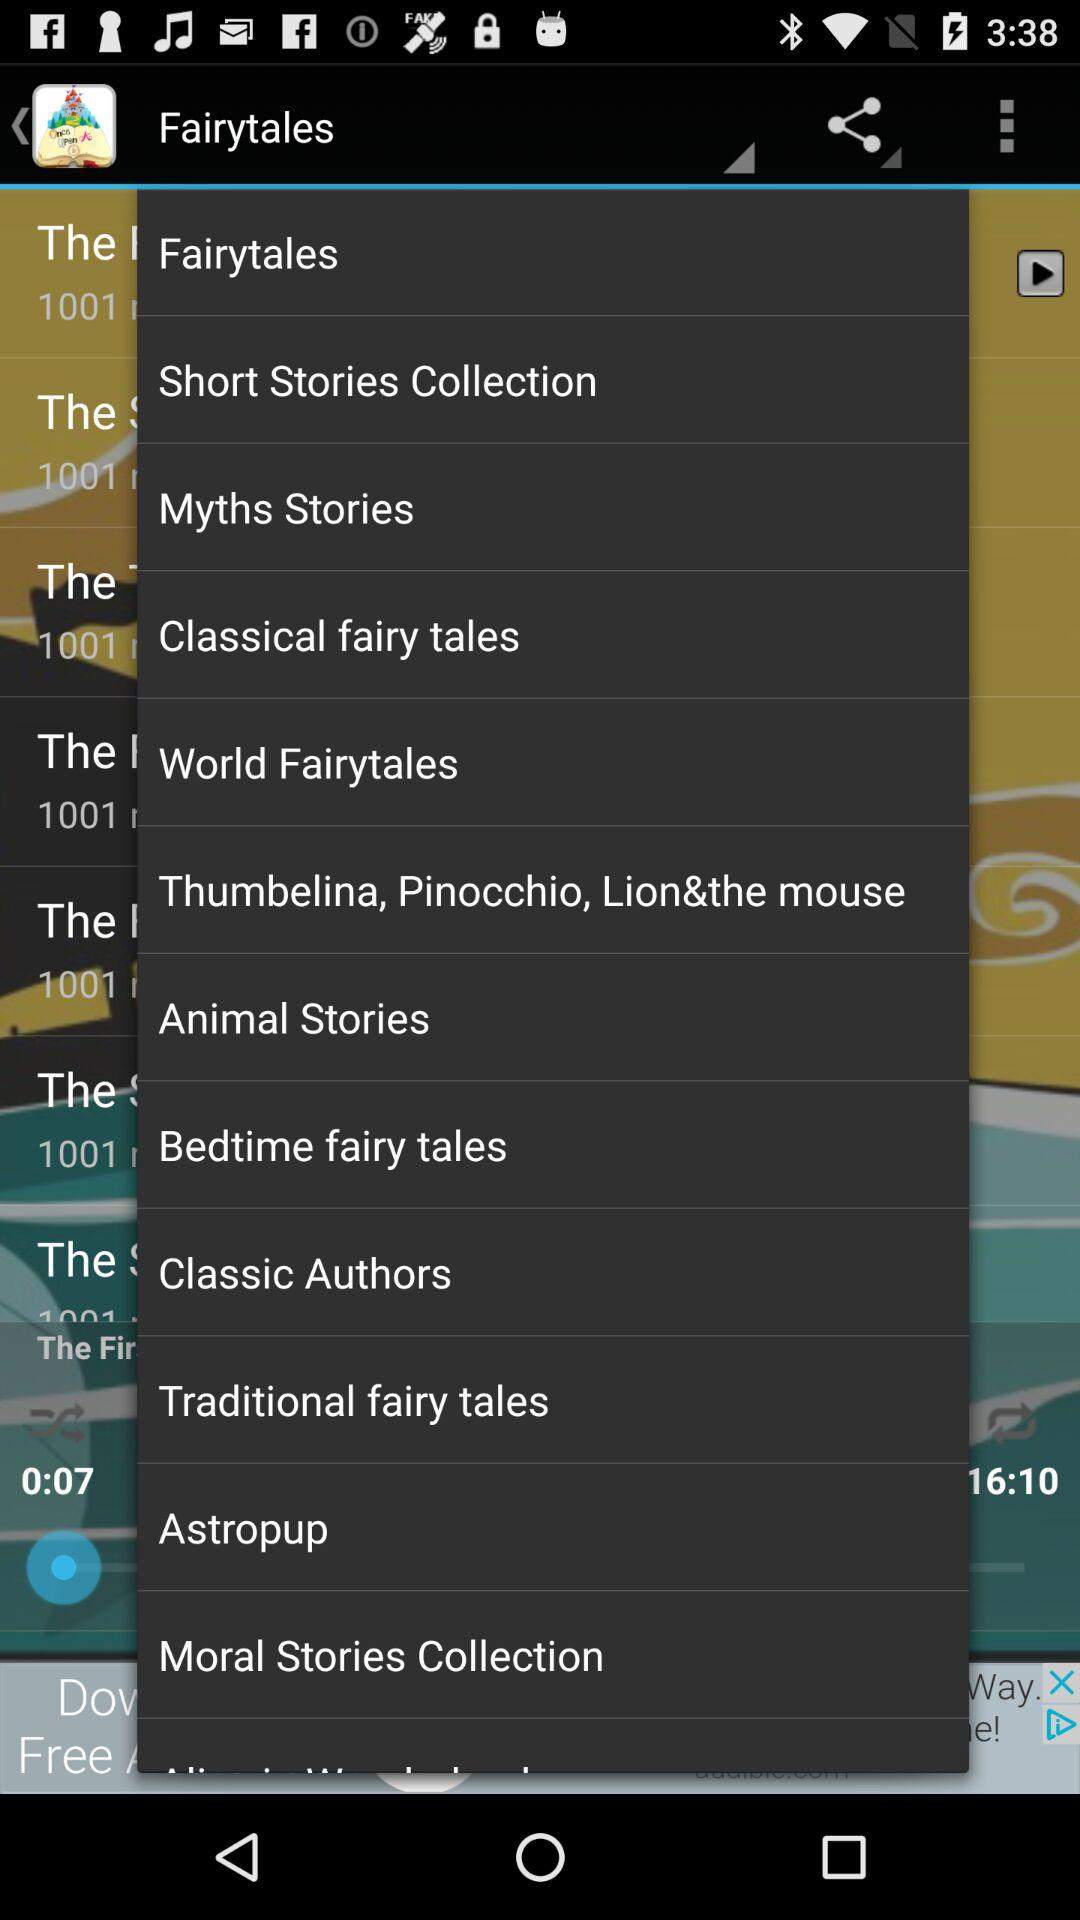What's the Duration of the track?
When the provided information is insufficient, respond with <no answer>. <no answer> 